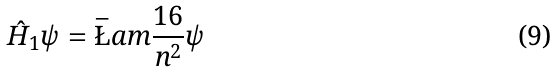Convert formula to latex. <formula><loc_0><loc_0><loc_500><loc_500>\hat { H } _ { 1 } \psi = \bar { \L } a m \frac { 1 6 } { n ^ { 2 } } \psi</formula> 